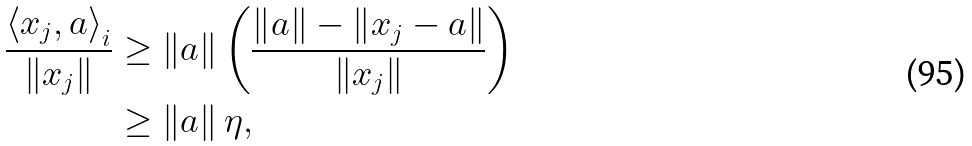Convert formula to latex. <formula><loc_0><loc_0><loc_500><loc_500>\frac { \left \langle x _ { j } , a \right \rangle _ { i } } { \left \| x _ { j } \right \| } & \geq \left \| a \right \| \left ( \frac { \left \| a \right \| - \left \| x _ { j } - a \right \| } { \left \| x _ { j } \right \| } \right ) \\ & \geq \left \| a \right \| \eta ,</formula> 